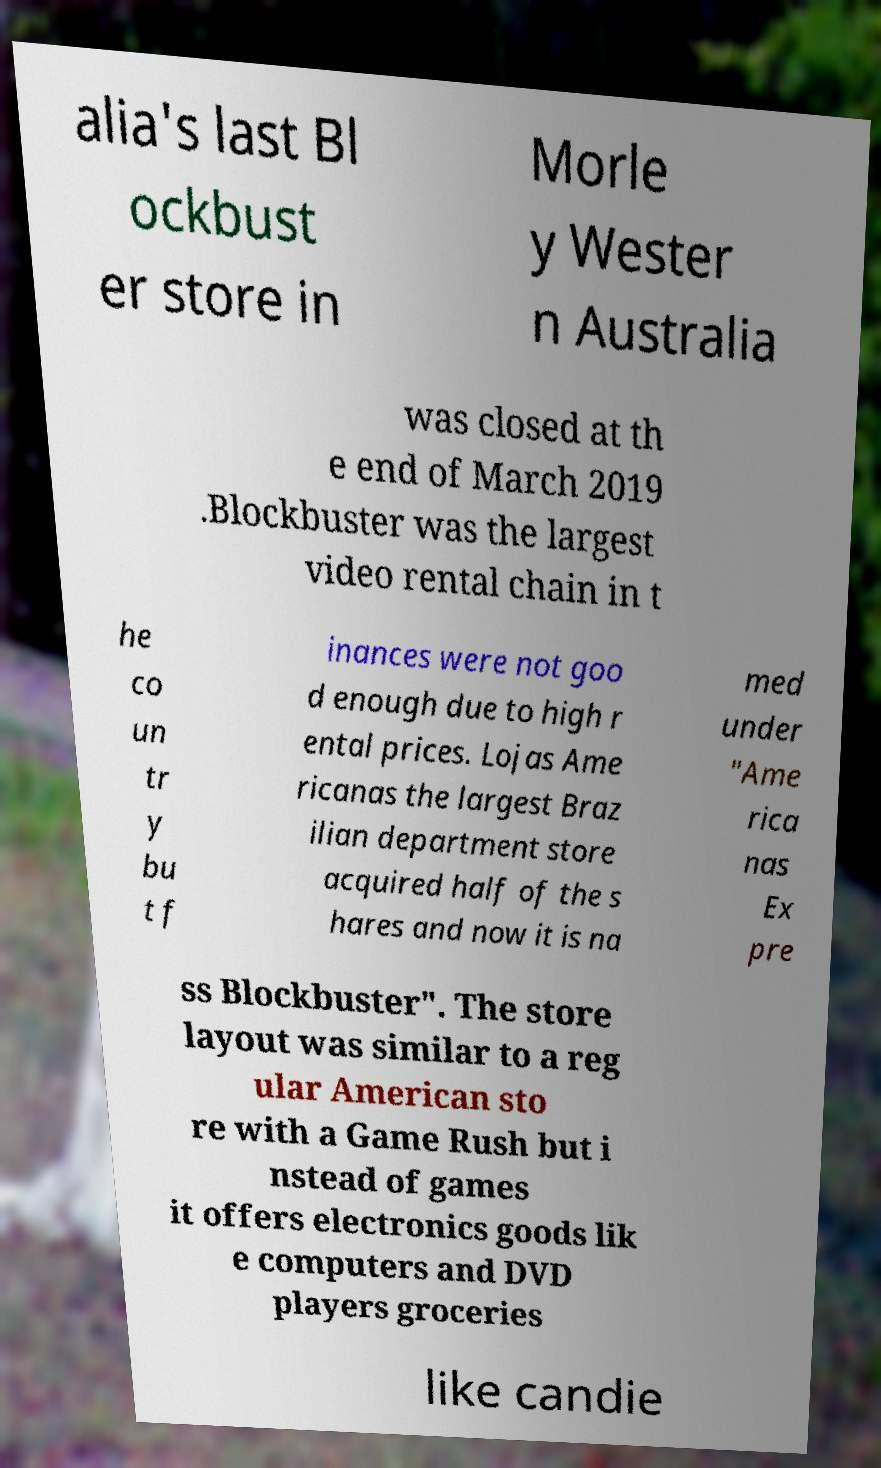What messages or text are displayed in this image? I need them in a readable, typed format. alia's last Bl ockbust er store in Morle y Wester n Australia was closed at th e end of March 2019 .Blockbuster was the largest video rental chain in t he co un tr y bu t f inances were not goo d enough due to high r ental prices. Lojas Ame ricanas the largest Braz ilian department store acquired half of the s hares and now it is na med under "Ame rica nas Ex pre ss Blockbuster". The store layout was similar to a reg ular American sto re with a Game Rush but i nstead of games it offers electronics goods lik e computers and DVD players groceries like candie 